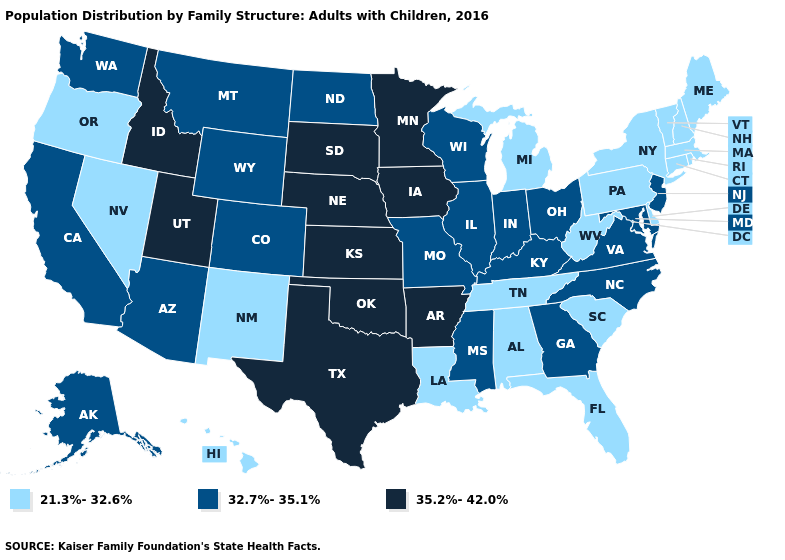What is the value of South Carolina?
Give a very brief answer. 21.3%-32.6%. Among the states that border Nevada , does Utah have the lowest value?
Concise answer only. No. What is the lowest value in the Northeast?
Quick response, please. 21.3%-32.6%. What is the value of Oregon?
Give a very brief answer. 21.3%-32.6%. How many symbols are there in the legend?
Concise answer only. 3. What is the value of North Carolina?
Short answer required. 32.7%-35.1%. What is the highest value in states that border Mississippi?
Be succinct. 35.2%-42.0%. Name the states that have a value in the range 21.3%-32.6%?
Short answer required. Alabama, Connecticut, Delaware, Florida, Hawaii, Louisiana, Maine, Massachusetts, Michigan, Nevada, New Hampshire, New Mexico, New York, Oregon, Pennsylvania, Rhode Island, South Carolina, Tennessee, Vermont, West Virginia. Does Oklahoma have the highest value in the USA?
Short answer required. Yes. What is the value of California?
Be succinct. 32.7%-35.1%. What is the value of New Mexico?
Answer briefly. 21.3%-32.6%. What is the lowest value in states that border New Jersey?
Write a very short answer. 21.3%-32.6%. Which states have the lowest value in the MidWest?
Keep it brief. Michigan. What is the value of Kentucky?
Short answer required. 32.7%-35.1%. What is the lowest value in the South?
Concise answer only. 21.3%-32.6%. 